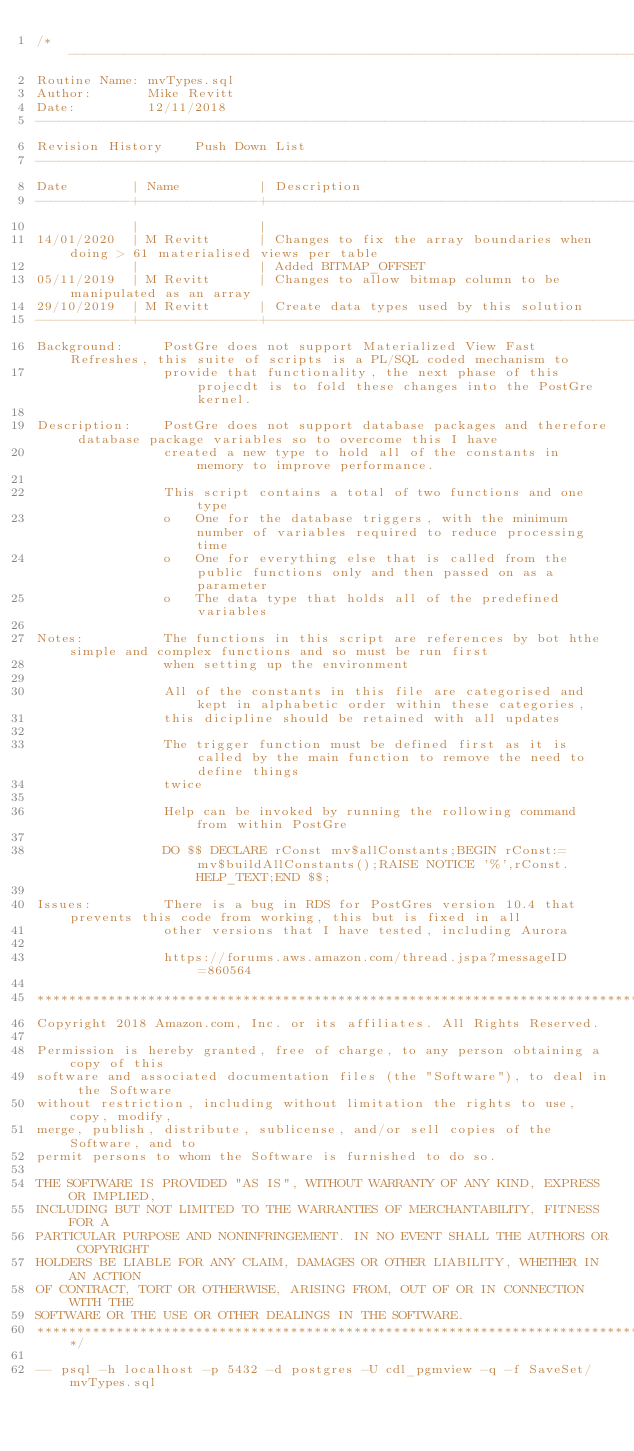<code> <loc_0><loc_0><loc_500><loc_500><_SQL_>/* ---------------------------------------------------------------------------------------------------------------------------------
Routine Name: mvTypes.sql
Author:       Mike Revitt
Date:         12/11/2018
------------------------------------------------------------------------------------------------------------------------------------
Revision History    Push Down List
------------------------------------------------------------------------------------------------------------------------------------
Date        | Name          | Description
------------+---------------+-------------------------------------------------------------------------------------------------------
            |               |
14/01/2020  | M Revitt      | Changes to fix the array boundaries when doing > 61 materialised views per table
            |               | Added BITMAP_OFFSET
05/11/2019  | M Revitt      | Changes to allow bitmap column to be manipulated as an array
29/10/2019  | M Revitt      | Create data types used by this solution
------------+---------------+-------------------------------------------------------------------------------------------------------
Background:     PostGre does not support Materialized View Fast Refreshes, this suite of scripts is a PL/SQL coded mechanism to
                provide that functionality, the next phase of this projecdt is to fold these changes into the PostGre kernel.

Description:    PostGre does not support database packages and therefore database package variables so to overcome this I have
                created a new type to hold all of the constants in memory to improve performance.

                This script contains a total of two functions and one type
                o   One for the database triggers, with the minimum number of variables required to reduce processing time
                o   One for everything else that is called from the public functions only and then passed on as a parameter
                o   The data type that holds all of the predefined variables

Notes:          The functions in this script are references by bot hthe simple and complex functions and so must be run first
                when setting up the environment

                All of the constants in this file are categorised and kept in alphabetic order within these categories,
                this dicipline should be retained with all updates

                The trigger function must be defined first as it is called by the main function to remove the need to define things
                twice

                Help can be invoked by running the rollowing command from within PostGre

                DO $$ DECLARE rConst mv$allConstants;BEGIN rConst:=mv$buildAllConstants();RAISE NOTICE '%',rConst.HELP_TEXT;END $$;

Issues:         There is a bug in RDS for PostGres version 10.4 that prevents this code from working, this but is fixed in all
                other versions that I have tested, including Aurora

                https://forums.aws.amazon.com/thread.jspa?messageID=860564

*************************************************************************************
Copyright 2018 Amazon.com, Inc. or its affiliates. All Rights Reserved.

Permission is hereby granted, free of charge, to any person obtaining a copy of this
software and associated documentation files (the "Software"), to deal in the Software
without restriction, including without limitation the rights to use, copy, modify,
merge, publish, distribute, sublicense, and/or sell copies of the Software, and to
permit persons to whom the Software is furnished to do so.

THE SOFTWARE IS PROVIDED "AS IS", WITHOUT WARRANTY OF ANY KIND, EXPRESS OR IMPLIED,
INCLUDING BUT NOT LIMITED TO THE WARRANTIES OF MERCHANTABILITY, FITNESS FOR A
PARTICULAR PURPOSE AND NONINFRINGEMENT. IN NO EVENT SHALL THE AUTHORS OR COPYRIGHT
HOLDERS BE LIABLE FOR ANY CLAIM, DAMAGES OR OTHER LIABILITY, WHETHER IN AN ACTION
OF CONTRACT, TORT OR OTHERWISE, ARISING FROM, OUT OF OR IN CONNECTION WITH THE
SOFTWARE OR THE USE OR OTHER DEALINGS IN THE SOFTWARE.
************************************************************************************/

-- psql -h localhost -p 5432 -d postgres -U cdl_pgmview -q -f SaveSet/mvTypes.sql
</code> 